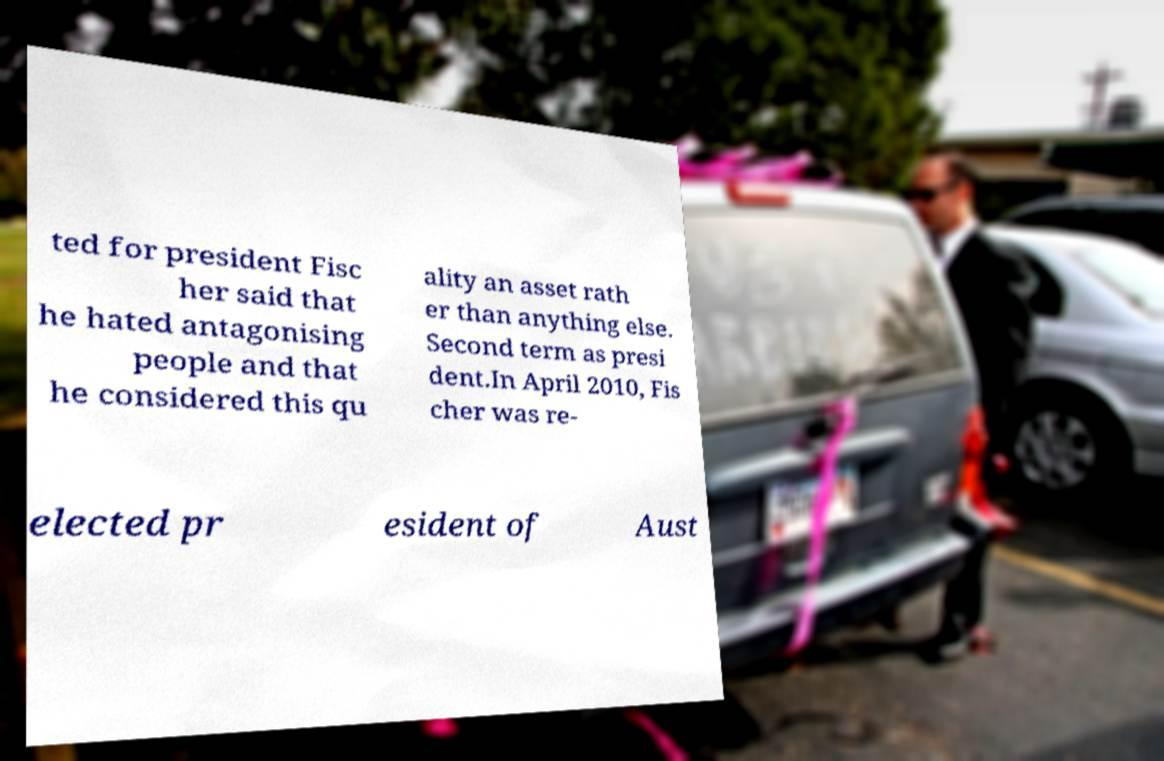Could you assist in decoding the text presented in this image and type it out clearly? ted for president Fisc her said that he hated antagonising people and that he considered this qu ality an asset rath er than anything else. Second term as presi dent.In April 2010, Fis cher was re- elected pr esident of Aust 